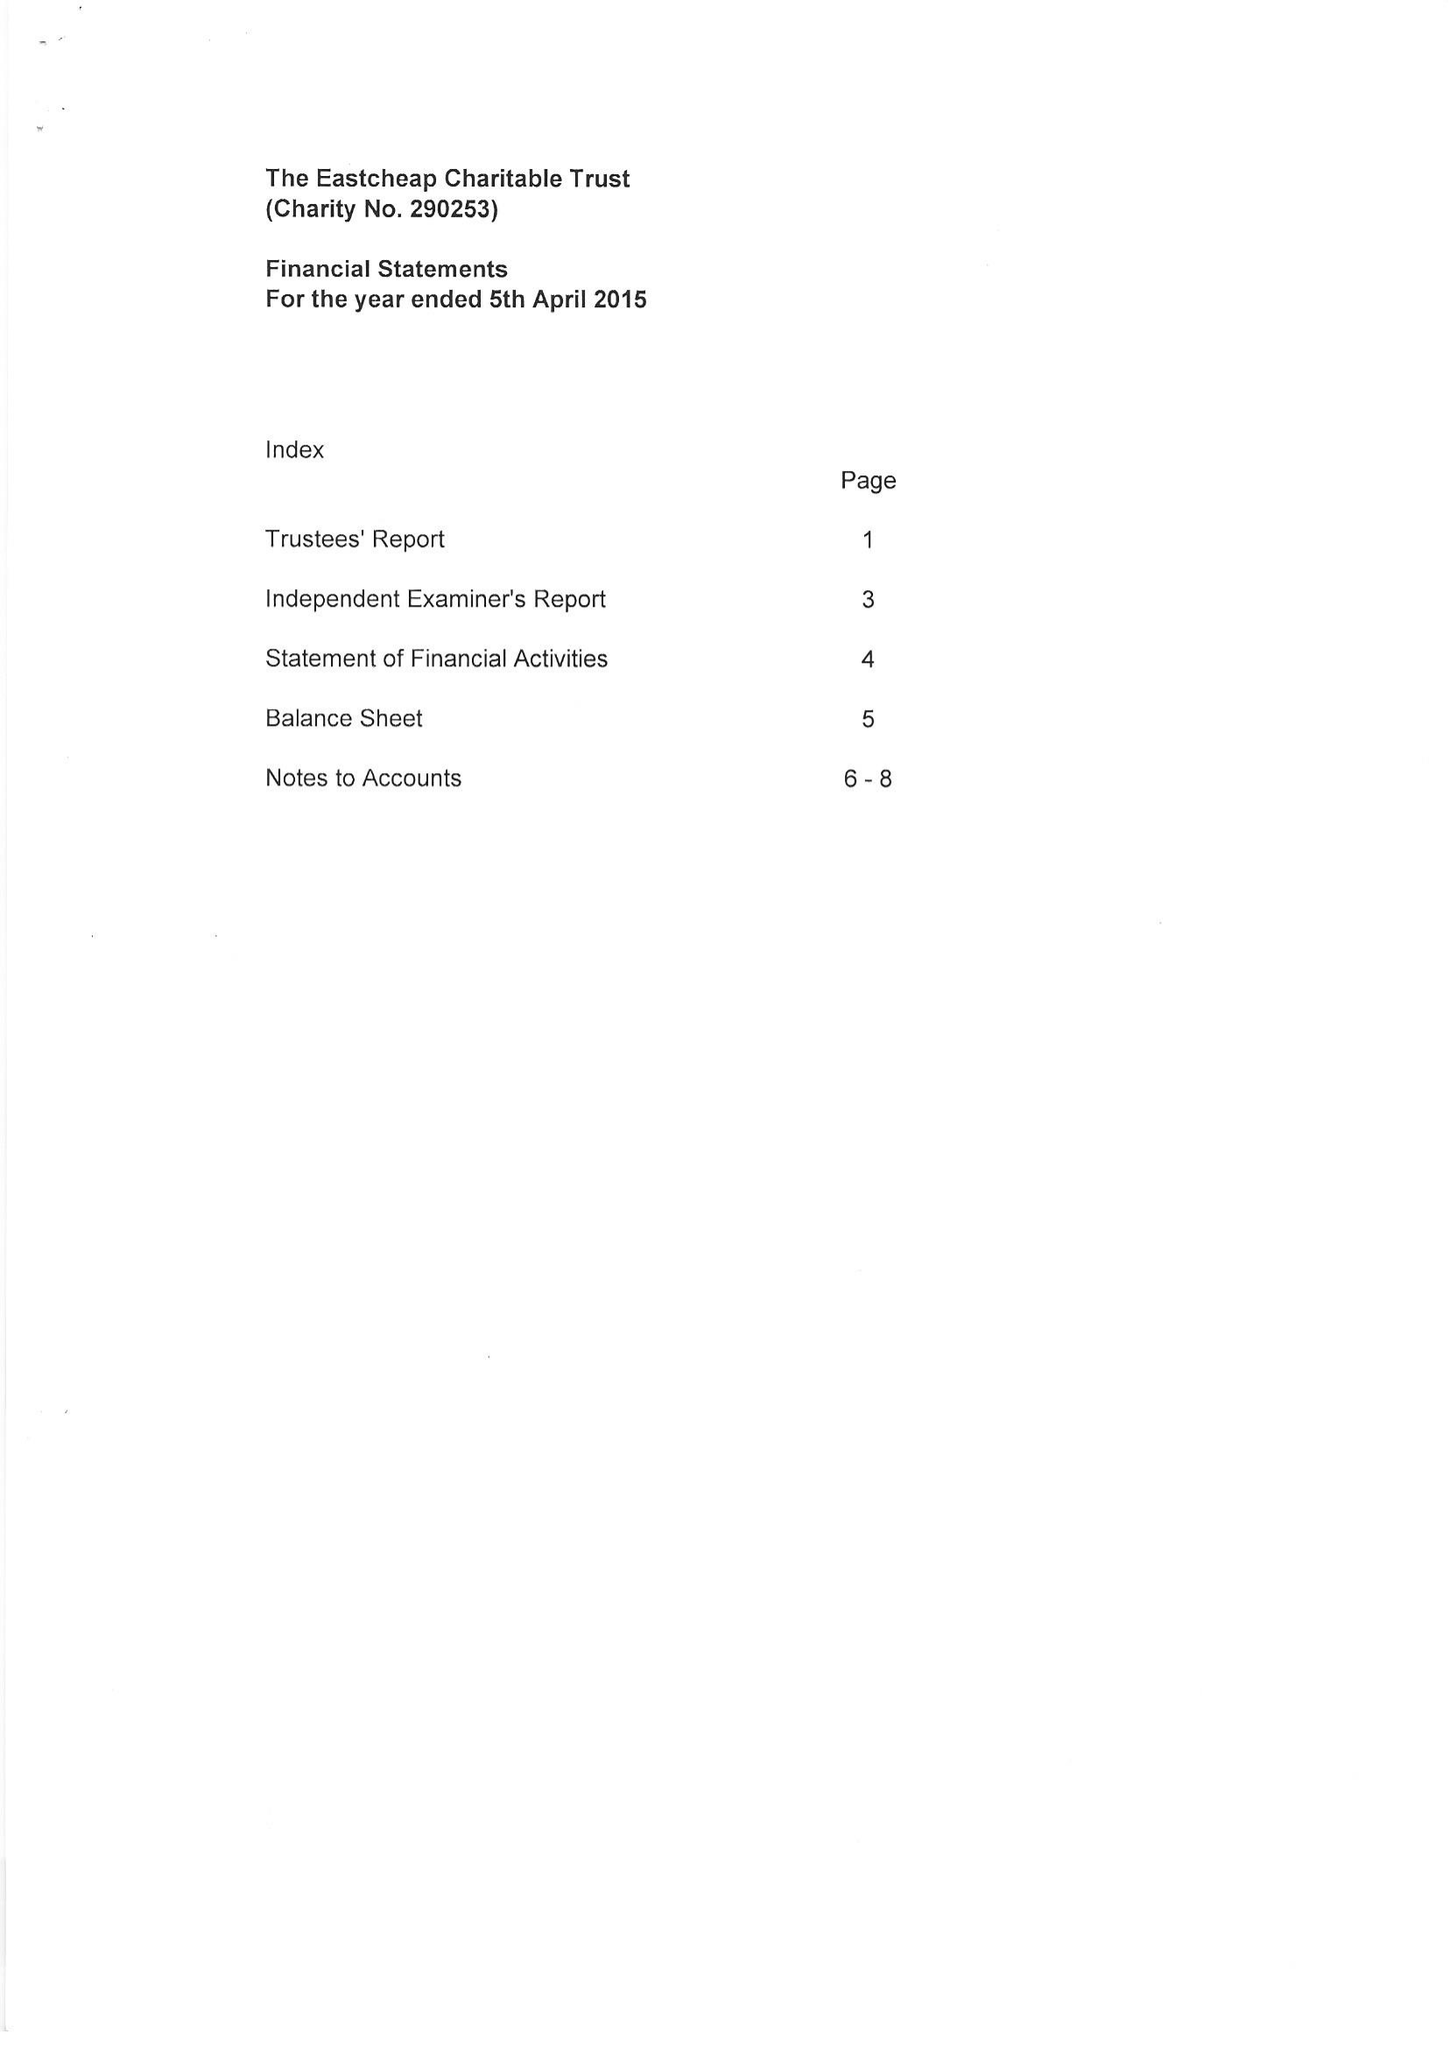What is the value for the charity_number?
Answer the question using a single word or phrase. 290253 